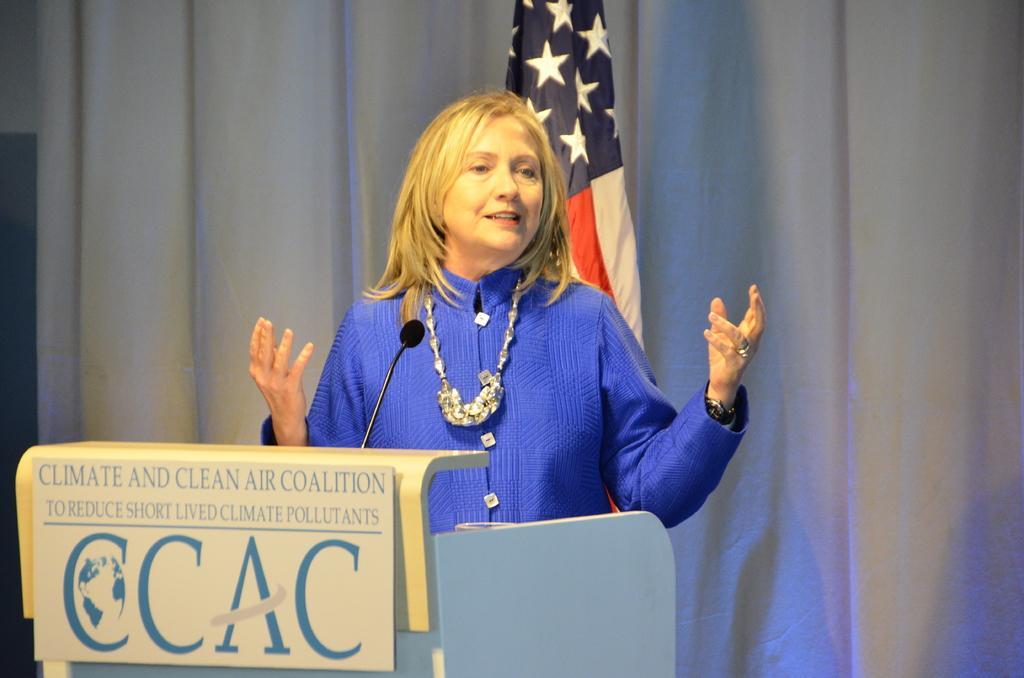Could you give a brief overview of what you see in this image? Here I can see a woman wearing blue color dress, standing in front of the podium and speaking. To the podium a board is attached on which I can see some text. At the back of this woman I can see a flag. In the background there is a white color curtain. 